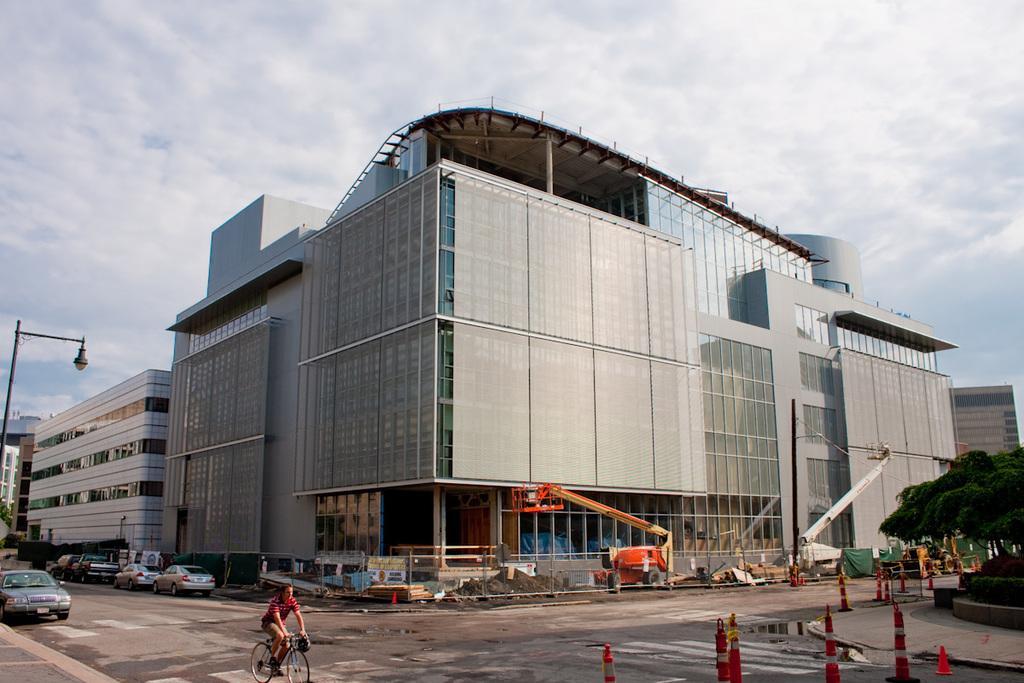Could you give a brief overview of what you see in this image? In this picture, we can see a person riding a bicycle, and we can see a few vehicles, cranes, road, poles, lights, trees, stairs, buildings with windows, and we can see the sky with clouds. 